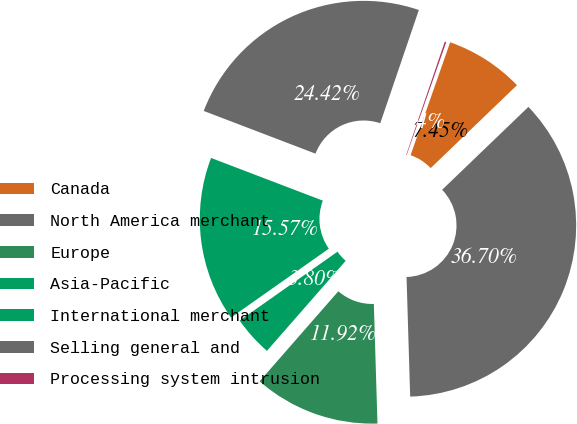Convert chart. <chart><loc_0><loc_0><loc_500><loc_500><pie_chart><fcel>Canada<fcel>North America merchant<fcel>Europe<fcel>Asia-Pacific<fcel>International merchant<fcel>Selling general and<fcel>Processing system intrusion<nl><fcel>7.45%<fcel>36.7%<fcel>11.92%<fcel>3.8%<fcel>15.57%<fcel>24.42%<fcel>0.14%<nl></chart> 